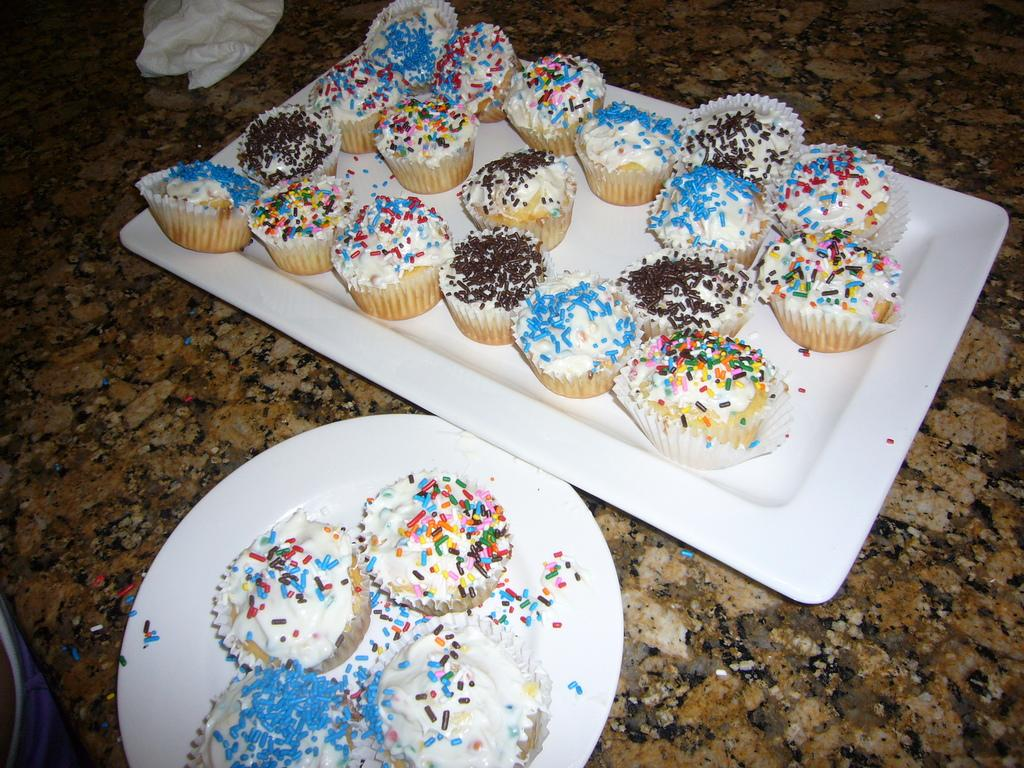What type of dessert can be seen in the image? There are cupcakes in the image. What is the color of the tray and plate that the cupcakes are on? The tray and plate are white in color. What type of surface are the cupcakes placed on? The cupcakes are placed on a stone surface. How many white color objects can be seen in the image? There is at least one white color object in the image, which is the tray or plate. What type of steel structure can be seen in the image? There is no steel structure present in the image; it features cupcakes on a tray and plate. What type of home is visible in the image? There is no home visible in the image; it features cupcakes on a tray and plate. 